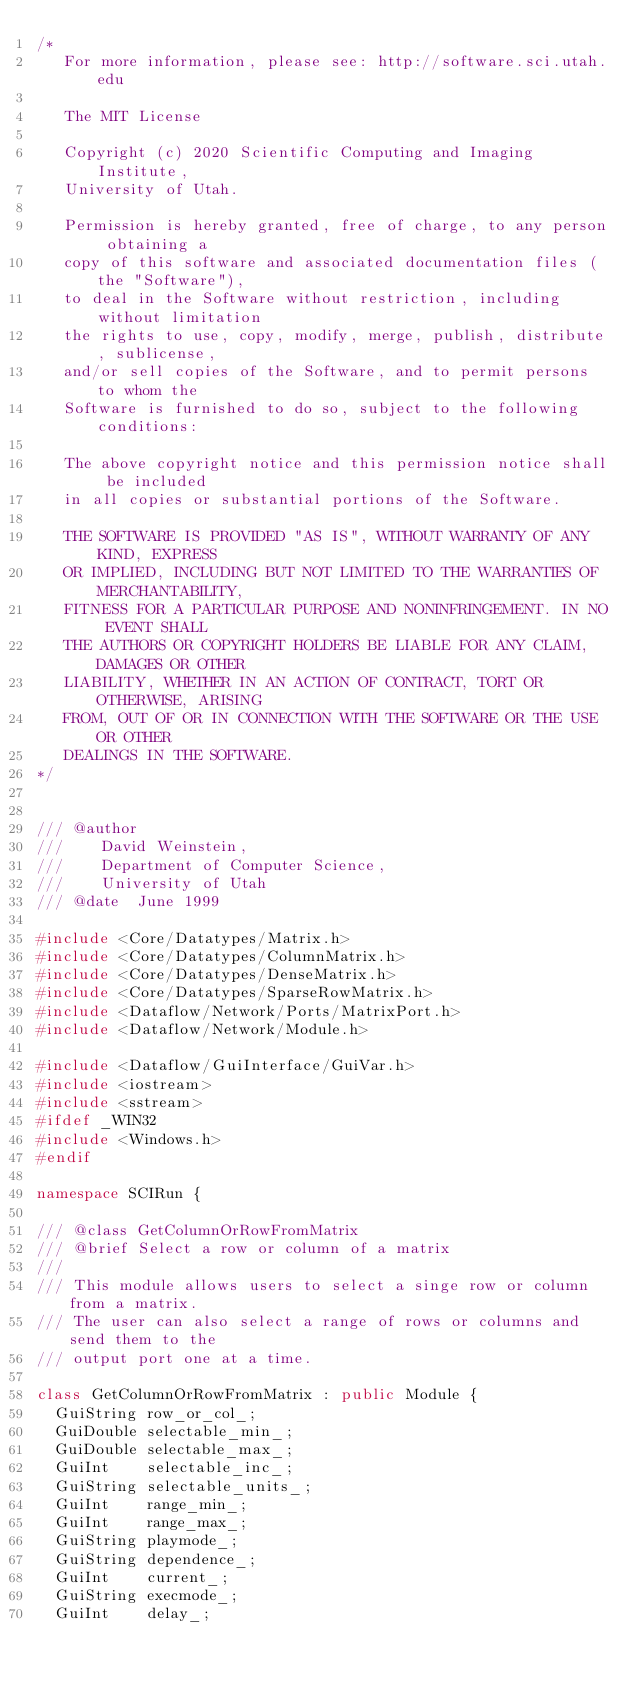<code> <loc_0><loc_0><loc_500><loc_500><_C++_>/*
   For more information, please see: http://software.sci.utah.edu

   The MIT License

   Copyright (c) 2020 Scientific Computing and Imaging Institute,
   University of Utah.

   Permission is hereby granted, free of charge, to any person obtaining a
   copy of this software and associated documentation files (the "Software"),
   to deal in the Software without restriction, including without limitation
   the rights to use, copy, modify, merge, publish, distribute, sublicense,
   and/or sell copies of the Software, and to permit persons to whom the
   Software is furnished to do so, subject to the following conditions:

   The above copyright notice and this permission notice shall be included
   in all copies or substantial portions of the Software.

   THE SOFTWARE IS PROVIDED "AS IS", WITHOUT WARRANTY OF ANY KIND, EXPRESS
   OR IMPLIED, INCLUDING BUT NOT LIMITED TO THE WARRANTIES OF MERCHANTABILITY,
   FITNESS FOR A PARTICULAR PURPOSE AND NONINFRINGEMENT. IN NO EVENT SHALL
   THE AUTHORS OR COPYRIGHT HOLDERS BE LIABLE FOR ANY CLAIM, DAMAGES OR OTHER
   LIABILITY, WHETHER IN AN ACTION OF CONTRACT, TORT OR OTHERWISE, ARISING
   FROM, OUT OF OR IN CONNECTION WITH THE SOFTWARE OR THE USE OR OTHER
   DEALINGS IN THE SOFTWARE.
*/


/// @author
///    David Weinstein,
///    Department of Computer Science,
///    University of Utah
/// @date  June 1999

#include <Core/Datatypes/Matrix.h>
#include <Core/Datatypes/ColumnMatrix.h>
#include <Core/Datatypes/DenseMatrix.h>
#include <Core/Datatypes/SparseRowMatrix.h>
#include <Dataflow/Network/Ports/MatrixPort.h>
#include <Dataflow/Network/Module.h>

#include <Dataflow/GuiInterface/GuiVar.h>
#include <iostream>
#include <sstream>
#ifdef _WIN32
#include <Windows.h>
#endif

namespace SCIRun {

/// @class GetColumnOrRowFromMatrix
/// @brief Select a row or column of a matrix
///
/// This module allows users to select a singe row or column from a matrix.
/// The user can also select a range of rows or columns and send them to the
/// output port one at a time.

class GetColumnOrRowFromMatrix : public Module {
  GuiString row_or_col_;
  GuiDouble selectable_min_;
  GuiDouble selectable_max_;
  GuiInt    selectable_inc_;
  GuiString selectable_units_;
  GuiInt    range_min_;
  GuiInt    range_max_;
  GuiString playmode_;
  GuiString dependence_;
  GuiInt    current_;
  GuiString execmode_;
  GuiInt    delay_;</code> 